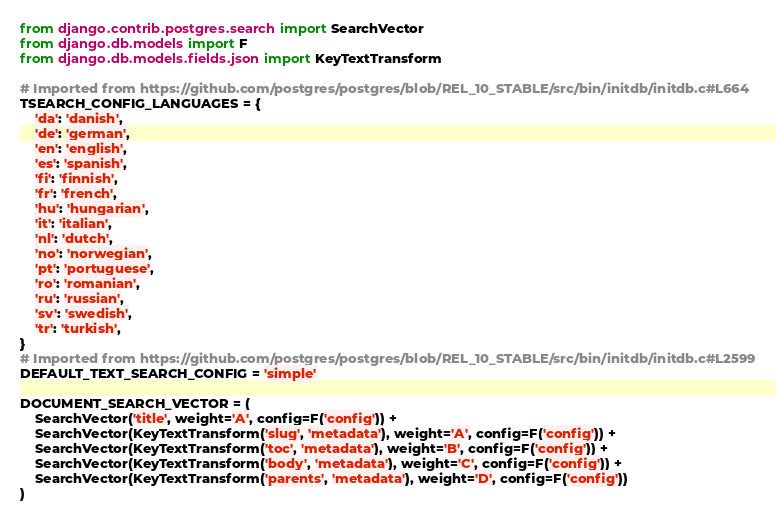<code> <loc_0><loc_0><loc_500><loc_500><_Python_>from django.contrib.postgres.search import SearchVector
from django.db.models import F
from django.db.models.fields.json import KeyTextTransform

# Imported from https://github.com/postgres/postgres/blob/REL_10_STABLE/src/bin/initdb/initdb.c#L664
TSEARCH_CONFIG_LANGUAGES = {
    'da': 'danish',
    'de': 'german',
    'en': 'english',
    'es': 'spanish',
    'fi': 'finnish',
    'fr': 'french',
    'hu': 'hungarian',
    'it': 'italian',
    'nl': 'dutch',
    'no': 'norwegian',
    'pt': 'portuguese',
    'ro': 'romanian',
    'ru': 'russian',
    'sv': 'swedish',
    'tr': 'turkish',
}
# Imported from https://github.com/postgres/postgres/blob/REL_10_STABLE/src/bin/initdb/initdb.c#L2599
DEFAULT_TEXT_SEARCH_CONFIG = 'simple'

DOCUMENT_SEARCH_VECTOR = (
    SearchVector('title', weight='A', config=F('config')) +
    SearchVector(KeyTextTransform('slug', 'metadata'), weight='A', config=F('config')) +
    SearchVector(KeyTextTransform('toc', 'metadata'), weight='B', config=F('config')) +
    SearchVector(KeyTextTransform('body', 'metadata'), weight='C', config=F('config')) +
    SearchVector(KeyTextTransform('parents', 'metadata'), weight='D', config=F('config'))
)
</code> 